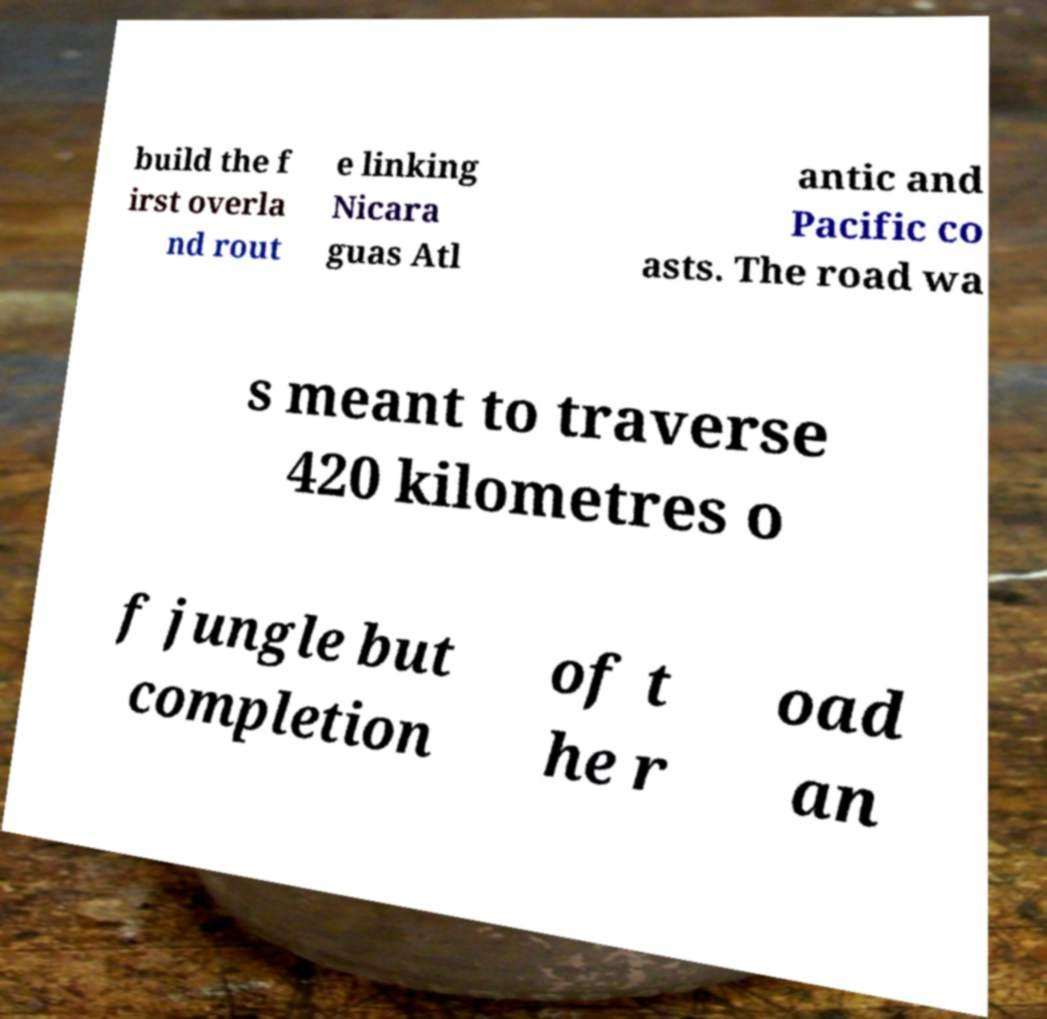I need the written content from this picture converted into text. Can you do that? build the f irst overla nd rout e linking Nicara guas Atl antic and Pacific co asts. The road wa s meant to traverse 420 kilometres o f jungle but completion of t he r oad an 